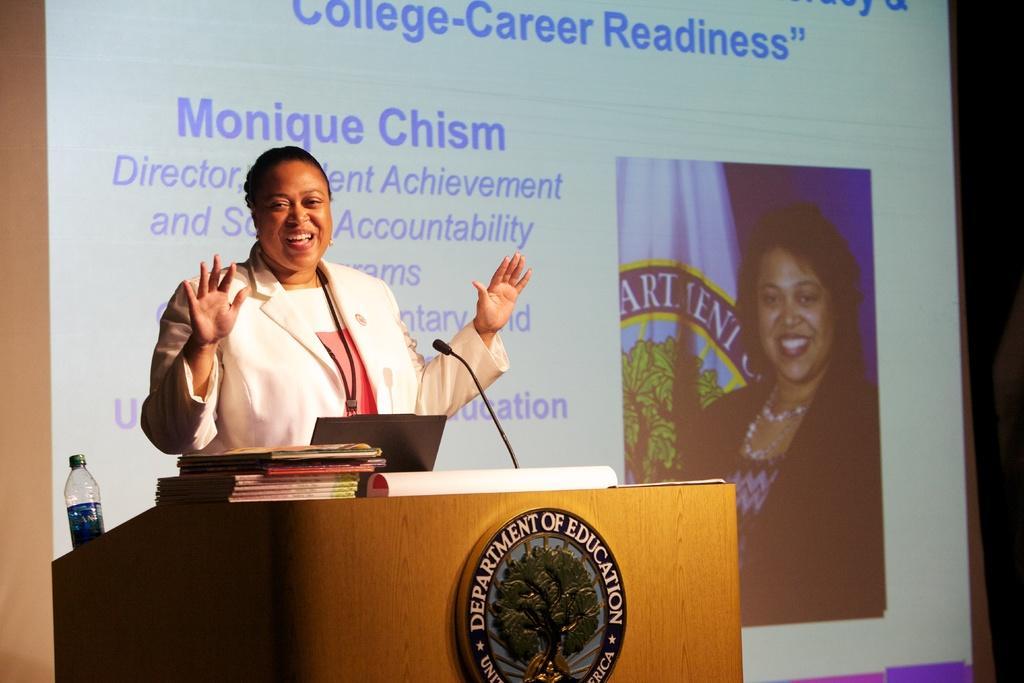In one or two sentences, can you explain what this image depicts? In the image there is a podium with logo on it. And also there is a bottle, laptop, mic and also there are books on the podium. Behind the podium there is a lady with white jacket is standing and she is smiling. Behind her there is a screen with something written on it and also there is an image of a lady. 